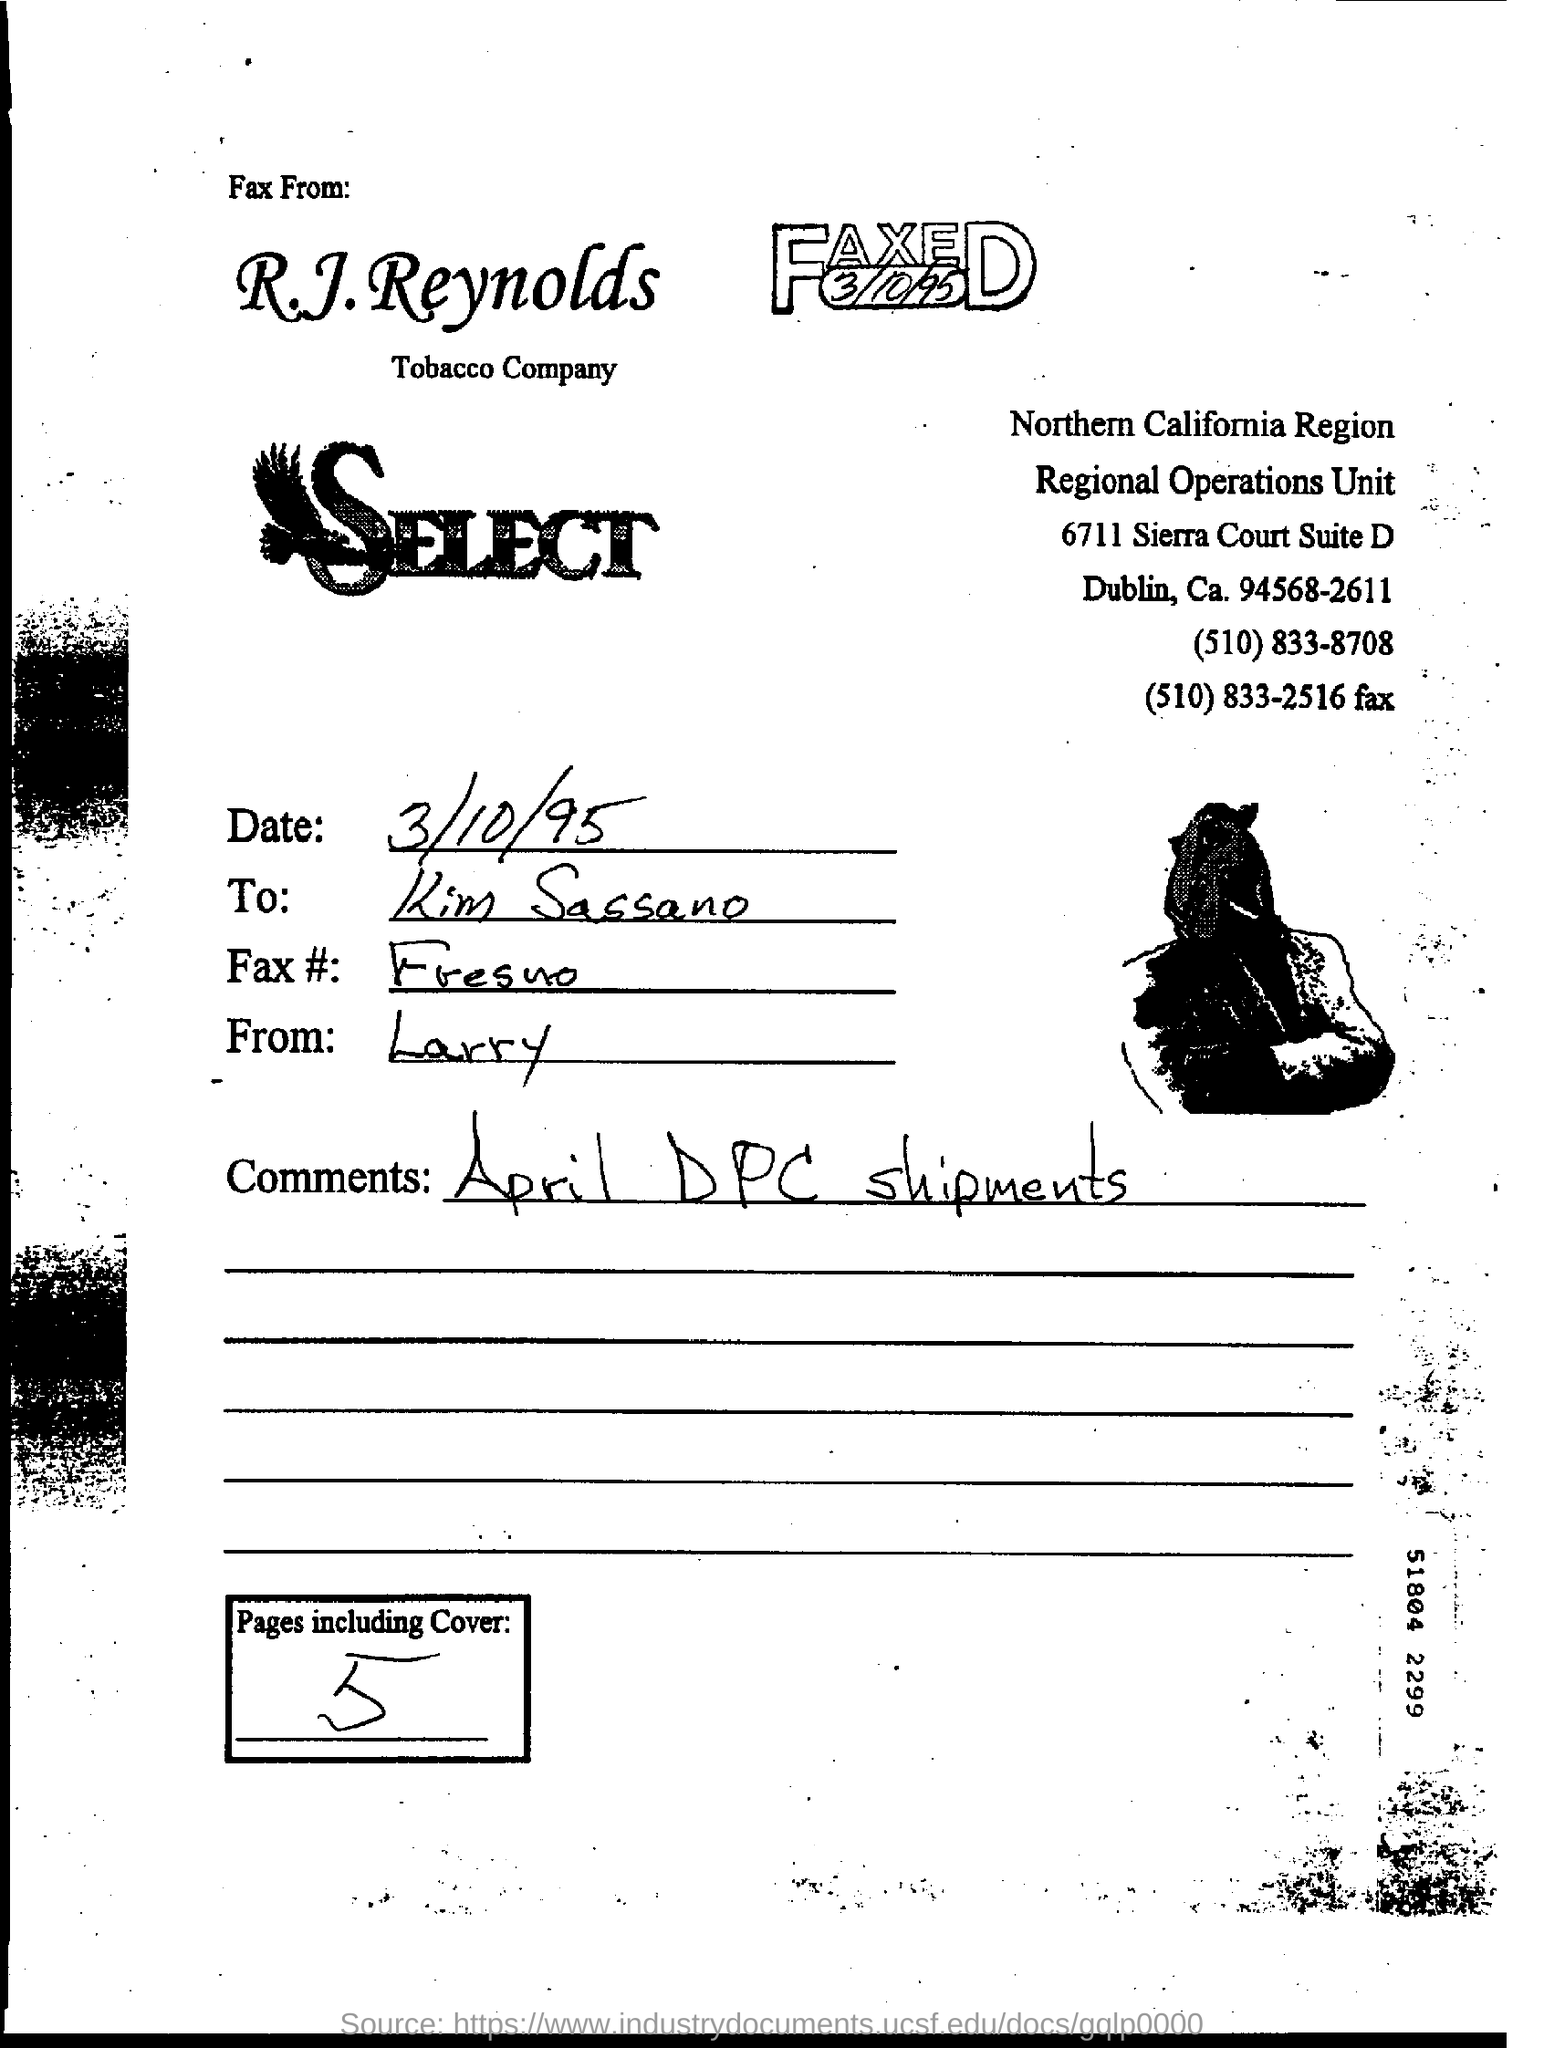Give some essential details in this illustration. The fax is addressed to Kim Sassano. The comments in the fax pertain to April DPC shipments. The date of the fax is March 10, 1995. 